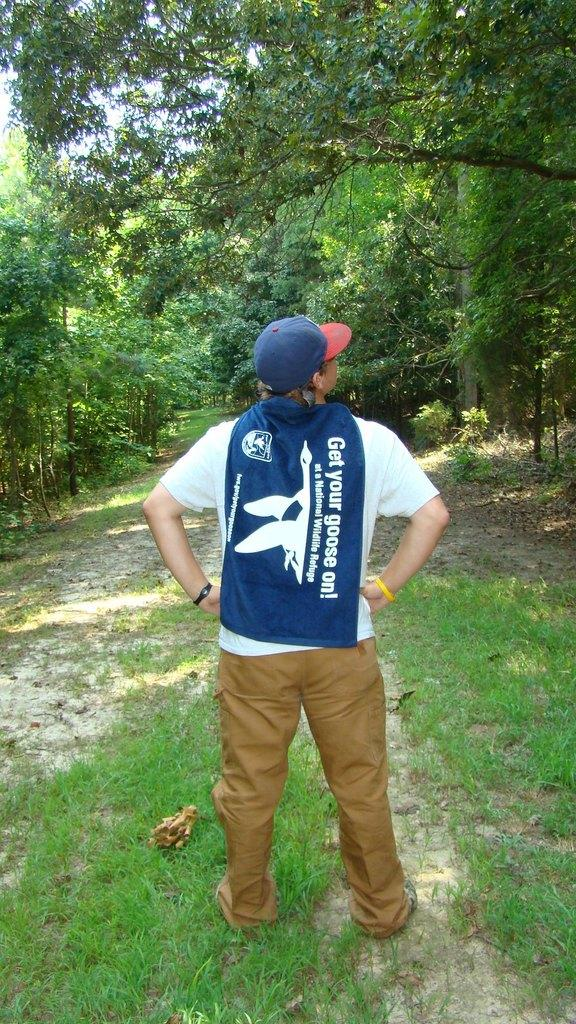<image>
Summarize the visual content of the image. The guy has a sweatshirt around his back that helps protect geese through a foundation. 